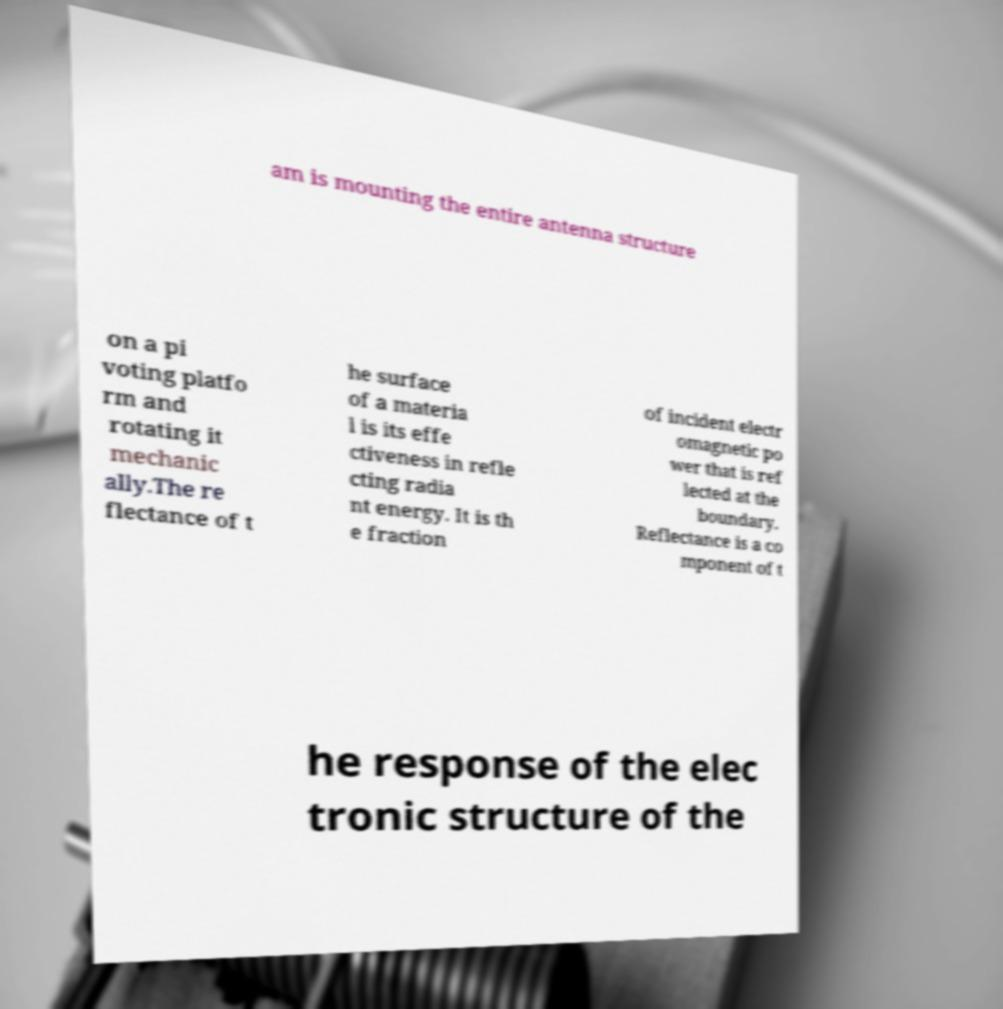Can you accurately transcribe the text from the provided image for me? am is mounting the entire antenna structure on a pi voting platfo rm and rotating it mechanic ally.The re flectance of t he surface of a materia l is its effe ctiveness in refle cting radia nt energy. It is th e fraction of incident electr omagnetic po wer that is ref lected at the boundary. Reflectance is a co mponent of t he response of the elec tronic structure of the 